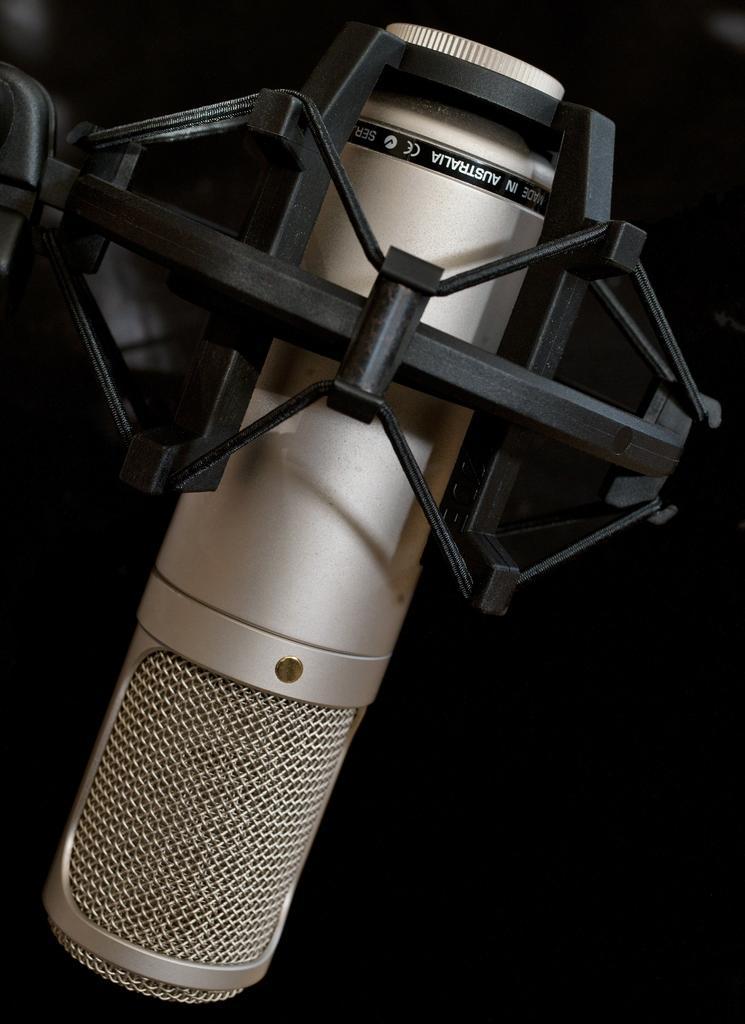Describe this image in one or two sentences. In the image there is a mic mounted to a stand. 